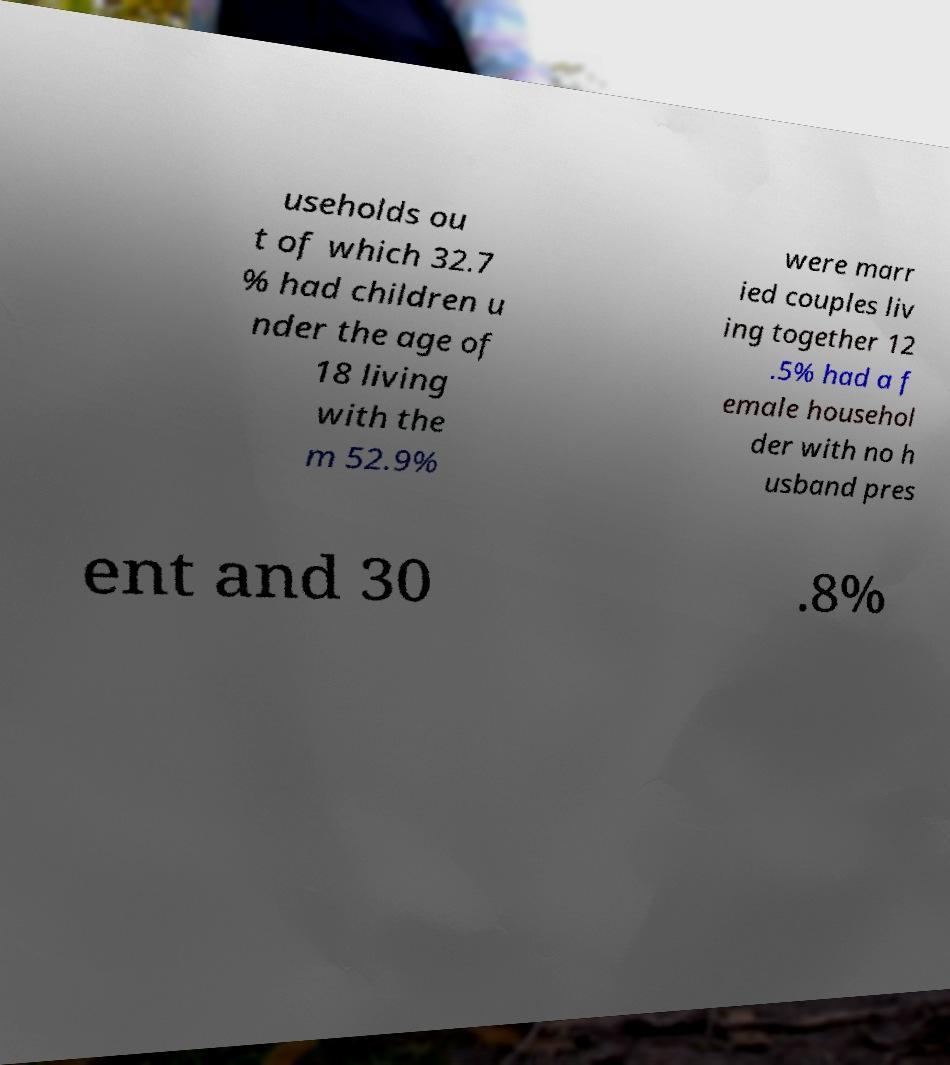Can you read and provide the text displayed in the image?This photo seems to have some interesting text. Can you extract and type it out for me? useholds ou t of which 32.7 % had children u nder the age of 18 living with the m 52.9% were marr ied couples liv ing together 12 .5% had a f emale househol der with no h usband pres ent and 30 .8% 